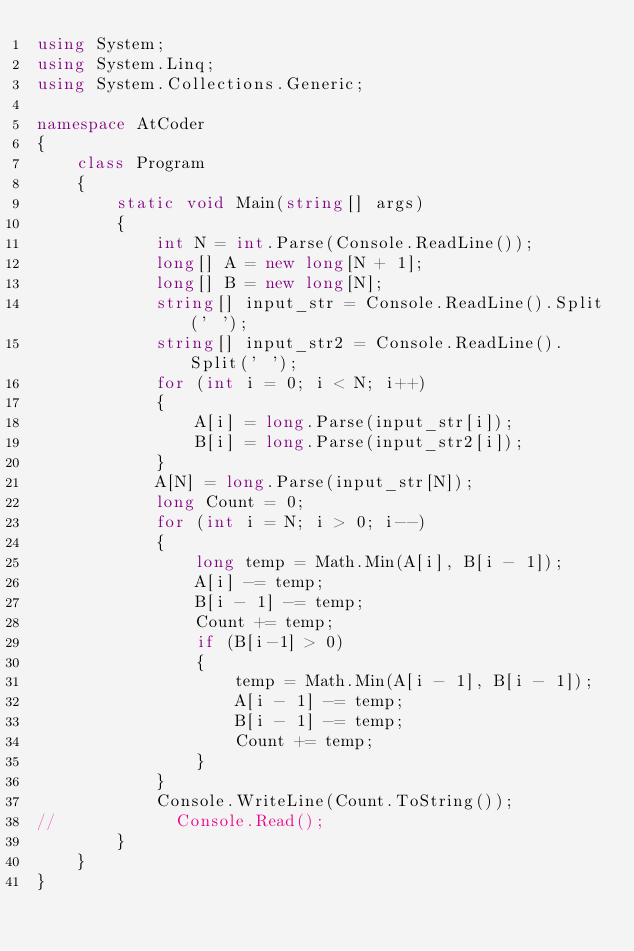<code> <loc_0><loc_0><loc_500><loc_500><_C#_>using System;
using System.Linq;
using System.Collections.Generic;

namespace AtCoder
{
    class Program
    {
        static void Main(string[] args)
        {
            int N = int.Parse(Console.ReadLine());
            long[] A = new long[N + 1];
            long[] B = new long[N];
            string[] input_str = Console.ReadLine().Split(' ');
            string[] input_str2 = Console.ReadLine().Split(' ');
            for (int i = 0; i < N; i++)
            {
                A[i] = long.Parse(input_str[i]);
                B[i] = long.Parse(input_str2[i]);
            }
            A[N] = long.Parse(input_str[N]);
            long Count = 0;
            for (int i = N; i > 0; i--)
            {
                long temp = Math.Min(A[i], B[i - 1]);
                A[i] -= temp;
                B[i - 1] -= temp;
                Count += temp;
                if (B[i-1] > 0)
                {
                    temp = Math.Min(A[i - 1], B[i - 1]);
                    A[i - 1] -= temp;
                    B[i - 1] -= temp;
                    Count += temp;
                }
            }
            Console.WriteLine(Count.ToString());
//            Console.Read();
        }
    }
}</code> 